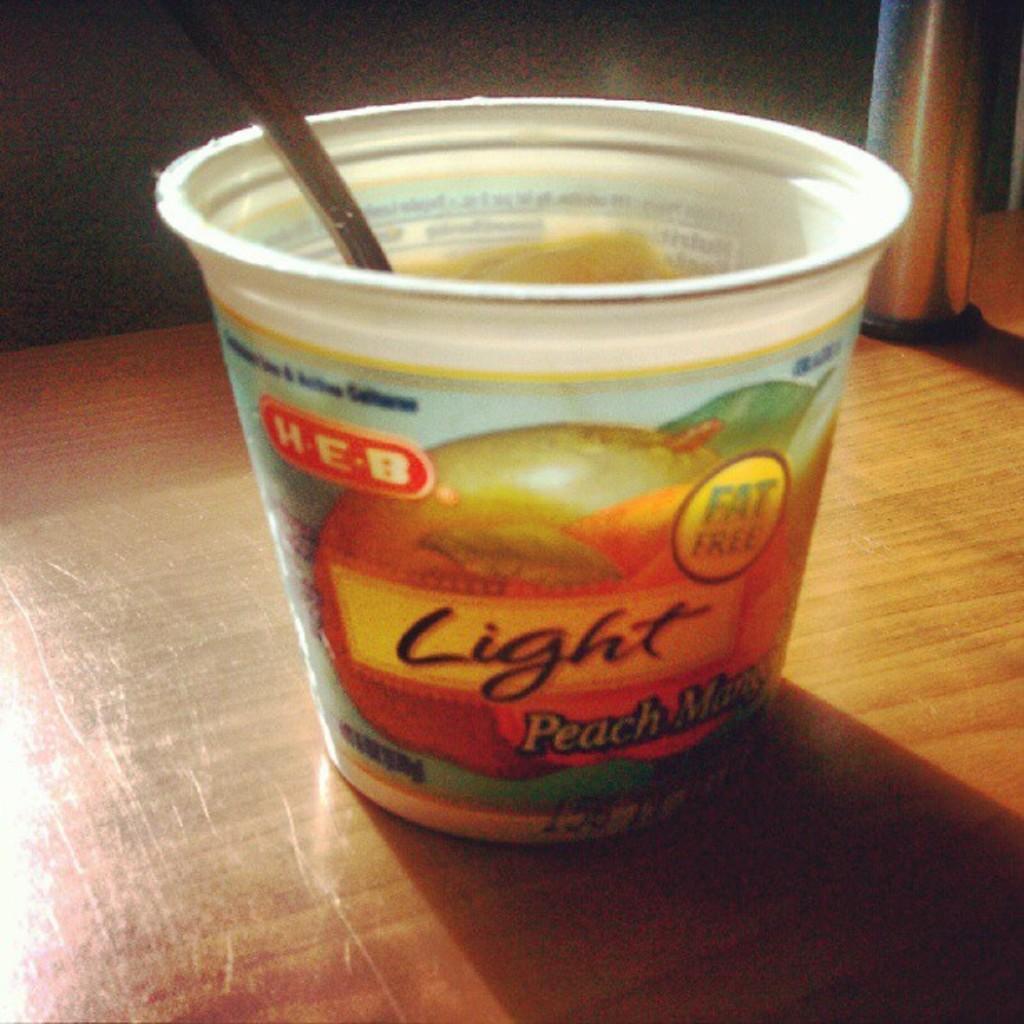Could you give a brief overview of what you see in this image? In this image, we can see a plastic cup, in that cup there is a spoon. 